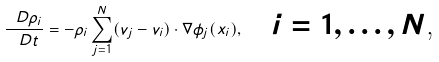<formula> <loc_0><loc_0><loc_500><loc_500>\frac { \ D \rho _ { i } } { \ D t } = - \rho _ { i } \sum _ { j = 1 } ^ { N } ( v _ { j } - v _ { i } ) \cdot \nabla \phi _ { j } ( x _ { i } ) , \quad \text {$i=1,\dots,N$,}</formula> 